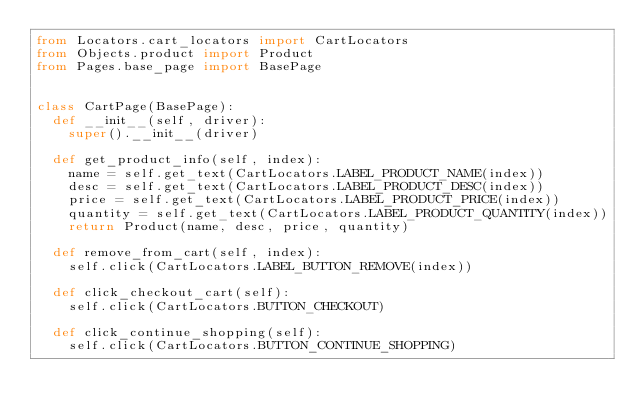Convert code to text. <code><loc_0><loc_0><loc_500><loc_500><_Python_>from Locators.cart_locators import CartLocators
from Objects.product import Product
from Pages.base_page import BasePage


class CartPage(BasePage):
  def __init__(self, driver):
    super().__init__(driver)

  def get_product_info(self, index):
    name = self.get_text(CartLocators.LABEL_PRODUCT_NAME(index))
    desc = self.get_text(CartLocators.LABEL_PRODUCT_DESC(index))
    price = self.get_text(CartLocators.LABEL_PRODUCT_PRICE(index))
    quantity = self.get_text(CartLocators.LABEL_PRODUCT_QUANTITY(index))
    return Product(name, desc, price, quantity)

  def remove_from_cart(self, index):
    self.click(CartLocators.LABEL_BUTTON_REMOVE(index))

  def click_checkout_cart(self):
    self.click(CartLocators.BUTTON_CHECKOUT)

  def click_continue_shopping(self):
    self.click(CartLocators.BUTTON_CONTINUE_SHOPPING)
</code> 